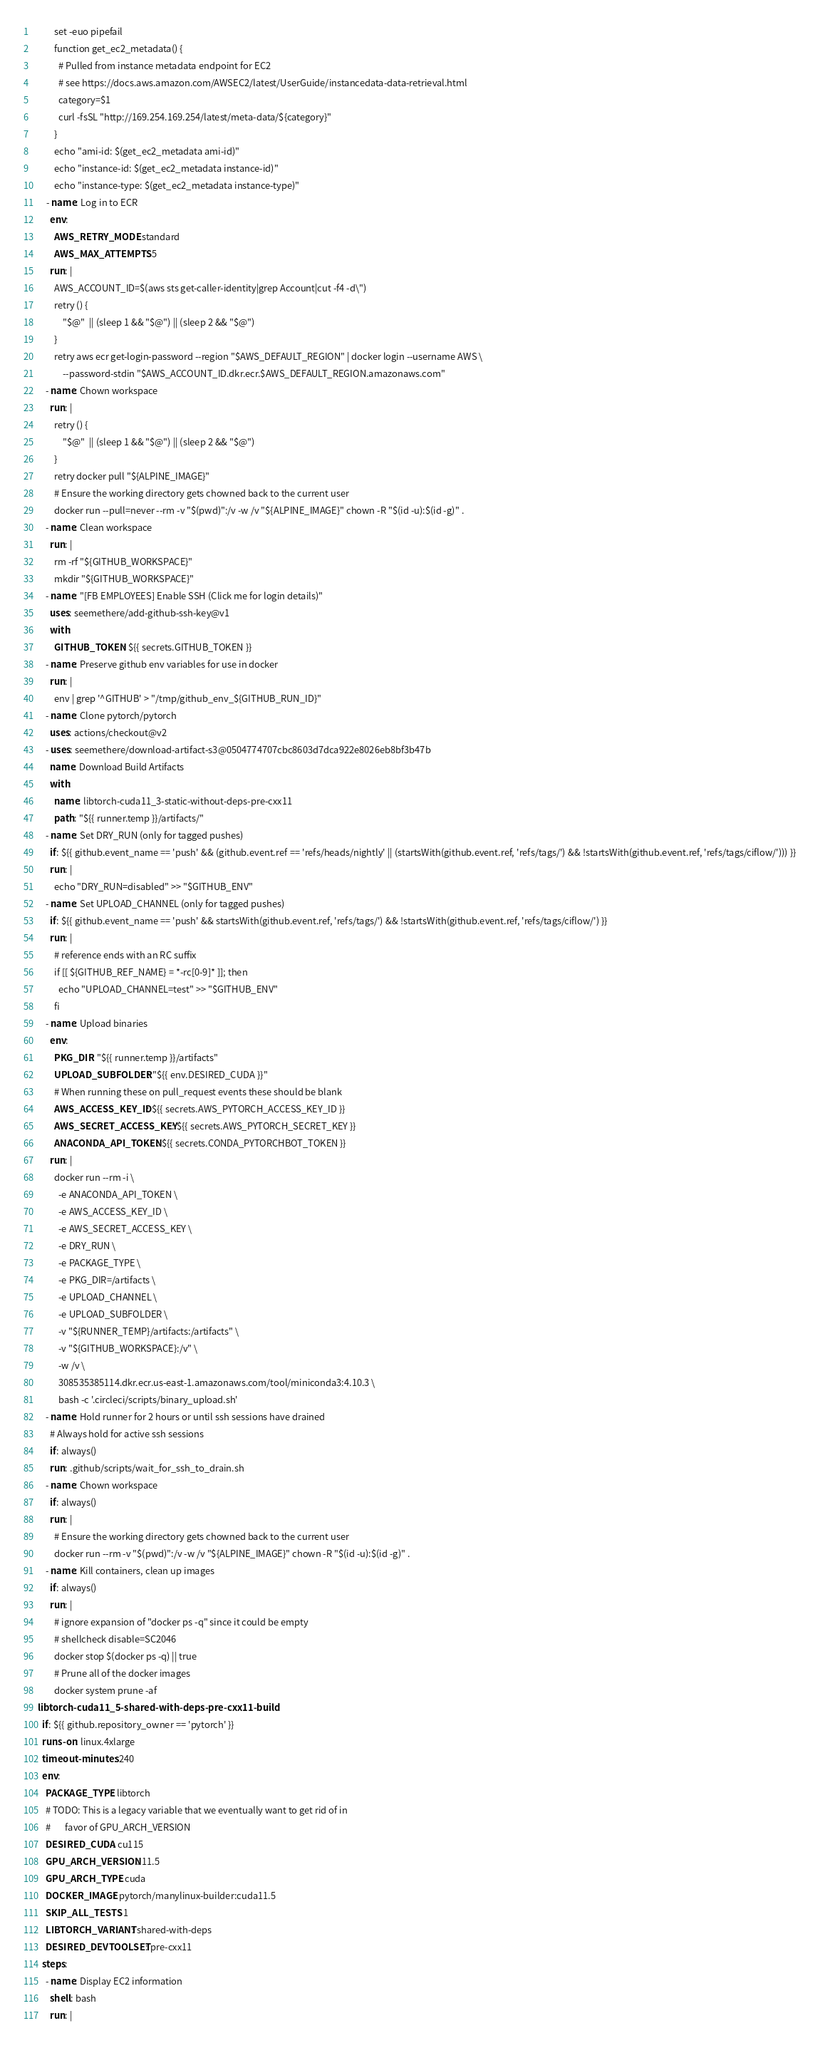<code> <loc_0><loc_0><loc_500><loc_500><_YAML_>          set -euo pipefail
          function get_ec2_metadata() {
            # Pulled from instance metadata endpoint for EC2
            # see https://docs.aws.amazon.com/AWSEC2/latest/UserGuide/instancedata-data-retrieval.html
            category=$1
            curl -fsSL "http://169.254.169.254/latest/meta-data/${category}"
          }
          echo "ami-id: $(get_ec2_metadata ami-id)"
          echo "instance-id: $(get_ec2_metadata instance-id)"
          echo "instance-type: $(get_ec2_metadata instance-type)"
      - name: Log in to ECR
        env:
          AWS_RETRY_MODE: standard
          AWS_MAX_ATTEMPTS: 5
        run: |
          AWS_ACCOUNT_ID=$(aws sts get-caller-identity|grep Account|cut -f4 -d\")
          retry () {
              "$@"  || (sleep 1 && "$@") || (sleep 2 && "$@")
          }
          retry aws ecr get-login-password --region "$AWS_DEFAULT_REGION" | docker login --username AWS \
              --password-stdin "$AWS_ACCOUNT_ID.dkr.ecr.$AWS_DEFAULT_REGION.amazonaws.com"
      - name: Chown workspace
        run: |
          retry () {
              "$@"  || (sleep 1 && "$@") || (sleep 2 && "$@")
          }
          retry docker pull "${ALPINE_IMAGE}"
          # Ensure the working directory gets chowned back to the current user
          docker run --pull=never --rm -v "$(pwd)":/v -w /v "${ALPINE_IMAGE}" chown -R "$(id -u):$(id -g)" .
      - name: Clean workspace
        run: |
          rm -rf "${GITHUB_WORKSPACE}"
          mkdir "${GITHUB_WORKSPACE}"
      - name: "[FB EMPLOYEES] Enable SSH (Click me for login details)"
        uses: seemethere/add-github-ssh-key@v1
        with:
          GITHUB_TOKEN: ${{ secrets.GITHUB_TOKEN }}
      - name: Preserve github env variables for use in docker
        run: |
          env | grep '^GITHUB' > "/tmp/github_env_${GITHUB_RUN_ID}"
      - name: Clone pytorch/pytorch
        uses: actions/checkout@v2
      - uses: seemethere/download-artifact-s3@0504774707cbc8603d7dca922e8026eb8bf3b47b
        name: Download Build Artifacts
        with:
          name: libtorch-cuda11_3-static-without-deps-pre-cxx11
          path: "${{ runner.temp }}/artifacts/"
      - name: Set DRY_RUN (only for tagged pushes)
        if: ${{ github.event_name == 'push' && (github.event.ref == 'refs/heads/nightly' || (startsWith(github.event.ref, 'refs/tags/') && !startsWith(github.event.ref, 'refs/tags/ciflow/'))) }}
        run: |
          echo "DRY_RUN=disabled" >> "$GITHUB_ENV"
      - name: Set UPLOAD_CHANNEL (only for tagged pushes)
        if: ${{ github.event_name == 'push' && startsWith(github.event.ref, 'refs/tags/') && !startsWith(github.event.ref, 'refs/tags/ciflow/') }}
        run: |
          # reference ends with an RC suffix
          if [[ ${GITHUB_REF_NAME} = *-rc[0-9]* ]]; then
            echo "UPLOAD_CHANNEL=test" >> "$GITHUB_ENV"
          fi
      - name: Upload binaries
        env:
          PKG_DIR: "${{ runner.temp }}/artifacts"
          UPLOAD_SUBFOLDER: "${{ env.DESIRED_CUDA }}"
          # When running these on pull_request events these should be blank
          AWS_ACCESS_KEY_ID: ${{ secrets.AWS_PYTORCH_ACCESS_KEY_ID }}
          AWS_SECRET_ACCESS_KEY: ${{ secrets.AWS_PYTORCH_SECRET_KEY }}
          ANACONDA_API_TOKEN: ${{ secrets.CONDA_PYTORCHBOT_TOKEN }}
        run: |
          docker run --rm -i \
            -e ANACONDA_API_TOKEN \
            -e AWS_ACCESS_KEY_ID \
            -e AWS_SECRET_ACCESS_KEY \
            -e DRY_RUN \
            -e PACKAGE_TYPE \
            -e PKG_DIR=/artifacts \
            -e UPLOAD_CHANNEL \
            -e UPLOAD_SUBFOLDER \
            -v "${RUNNER_TEMP}/artifacts:/artifacts" \
            -v "${GITHUB_WORKSPACE}:/v" \
            -w /v \
            308535385114.dkr.ecr.us-east-1.amazonaws.com/tool/miniconda3:4.10.3 \
            bash -c '.circleci/scripts/binary_upload.sh'
      - name: Hold runner for 2 hours or until ssh sessions have drained
        # Always hold for active ssh sessions
        if: always()
        run: .github/scripts/wait_for_ssh_to_drain.sh
      - name: Chown workspace
        if: always()
        run: |
          # Ensure the working directory gets chowned back to the current user
          docker run --rm -v "$(pwd)":/v -w /v "${ALPINE_IMAGE}" chown -R "$(id -u):$(id -g)" .
      - name: Kill containers, clean up images
        if: always()
        run: |
          # ignore expansion of "docker ps -q" since it could be empty
          # shellcheck disable=SC2046
          docker stop $(docker ps -q) || true
          # Prune all of the docker images
          docker system prune -af
  libtorch-cuda11_5-shared-with-deps-pre-cxx11-build:
    if: ${{ github.repository_owner == 'pytorch' }}
    runs-on: linux.4xlarge
    timeout-minutes: 240
    env:
      PACKAGE_TYPE: libtorch
      # TODO: This is a legacy variable that we eventually want to get rid of in
      #       favor of GPU_ARCH_VERSION
      DESIRED_CUDA: cu115
      GPU_ARCH_VERSION: 11.5
      GPU_ARCH_TYPE: cuda
      DOCKER_IMAGE: pytorch/manylinux-builder:cuda11.5
      SKIP_ALL_TESTS: 1
      LIBTORCH_VARIANT: shared-with-deps
      DESIRED_DEVTOOLSET: pre-cxx11
    steps:
      - name: Display EC2 information
        shell: bash
        run: |</code> 